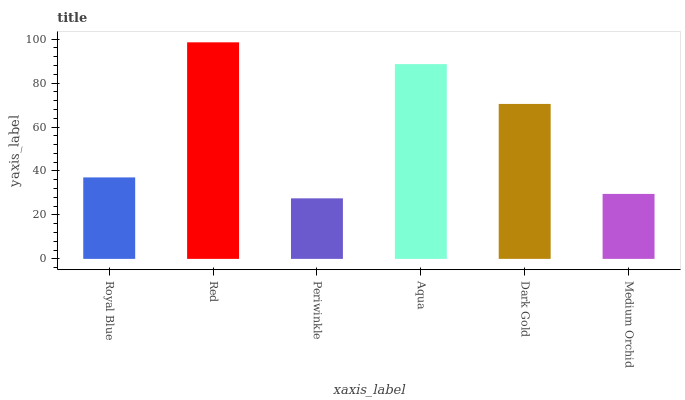Is Periwinkle the minimum?
Answer yes or no. Yes. Is Red the maximum?
Answer yes or no. Yes. Is Red the minimum?
Answer yes or no. No. Is Periwinkle the maximum?
Answer yes or no. No. Is Red greater than Periwinkle?
Answer yes or no. Yes. Is Periwinkle less than Red?
Answer yes or no. Yes. Is Periwinkle greater than Red?
Answer yes or no. No. Is Red less than Periwinkle?
Answer yes or no. No. Is Dark Gold the high median?
Answer yes or no. Yes. Is Royal Blue the low median?
Answer yes or no. Yes. Is Red the high median?
Answer yes or no. No. Is Periwinkle the low median?
Answer yes or no. No. 